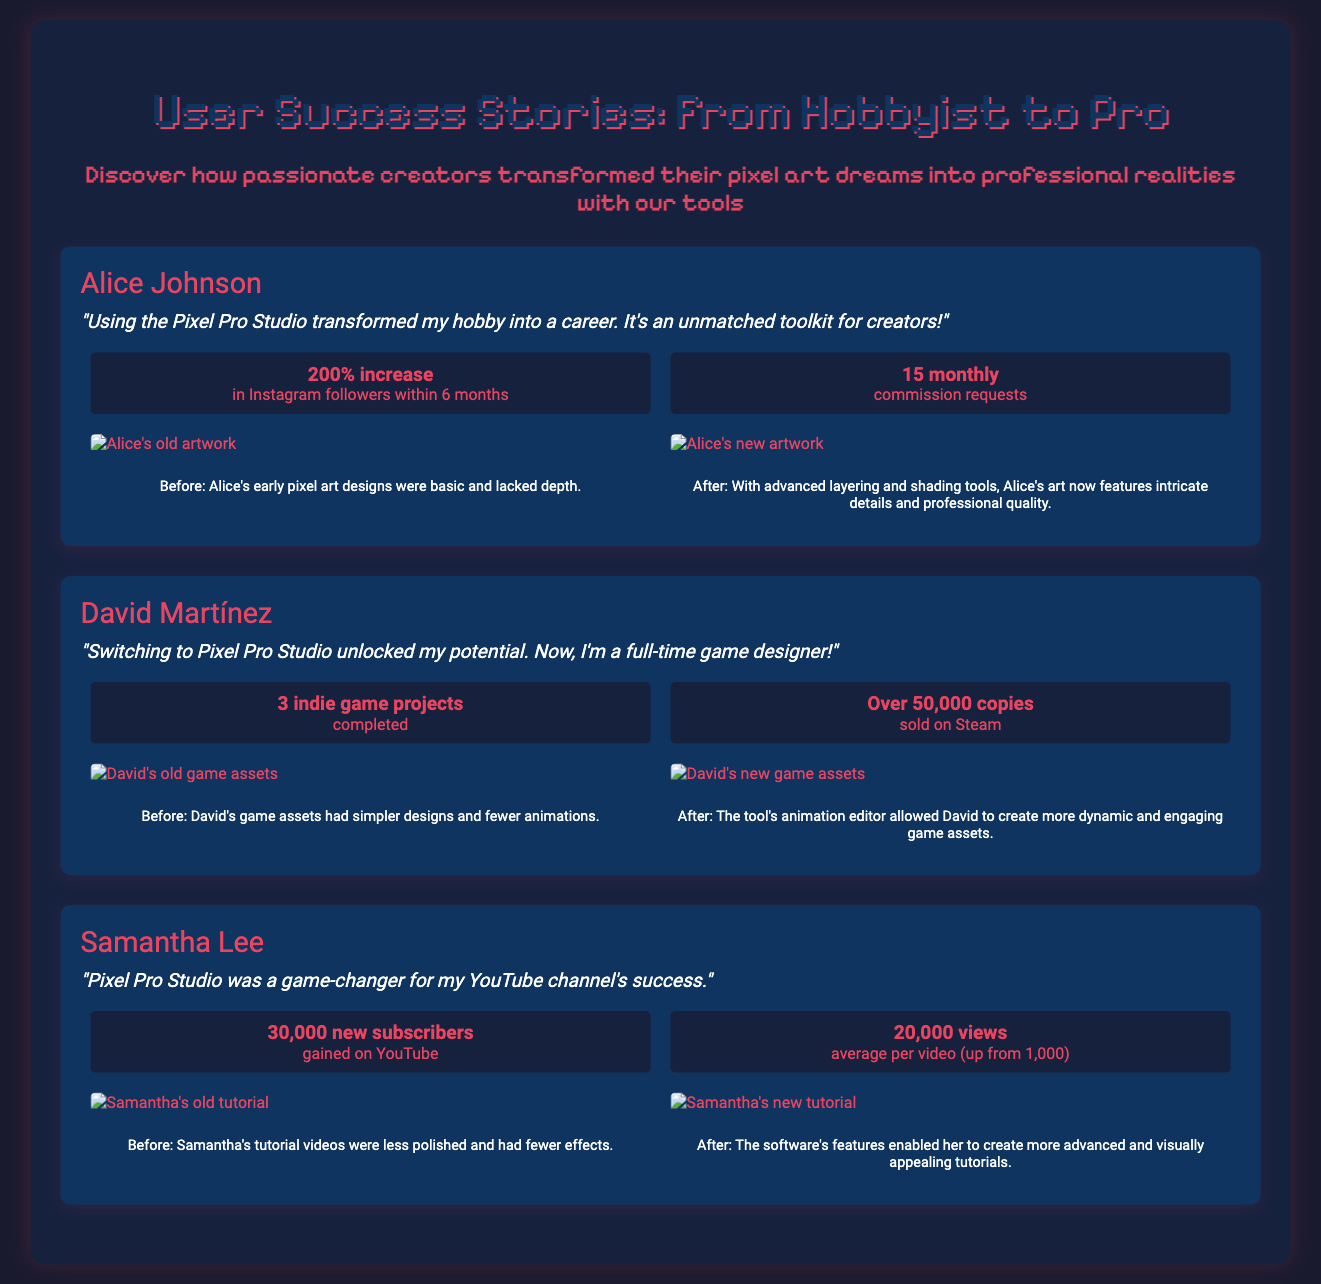What is the name of the first user featured? The first user featured in the document is identified as Alice Johnson.
Answer: Alice Johnson What did Alice Johnson experience as a percentage increase in followers? The document states that Alice experienced a 200% increase in her Instagram followers within 6 months.
Answer: 200% How many commission requests did Alice receive monthly after using the software? According to the document, Alice received 15 commission requests each month after using the software.
Answer: 15 monthly What is the title of the second user featured? The second user featured in the document is David Martínez.
Answer: David Martínez How many indie game projects has David Martínez completed? The document indicates that David has completed 3 indie game projects.
Answer: 3 indie game projects What was the old average views per video for Samantha Lee before using the software? The document mentions that Samantha's old average was 1,000 views per video.
Answer: 1,000 How many new subscribers did Samantha Lee gain on YouTube? The document states that Samantha gained 30,000 new subscribers on YouTube.
Answer: 30,000 new subscribers What feature of the software helped David create dynamic game assets? The document specifies that the animation editor in the tool allowed David to create more dynamic game assets.
Answer: Animation editor What transformation did Samantha Lee's tutorial videos undergo? According to the document, her videos became more advanced and visually appealing after using the software.
Answer: More advanced and visually appealing 